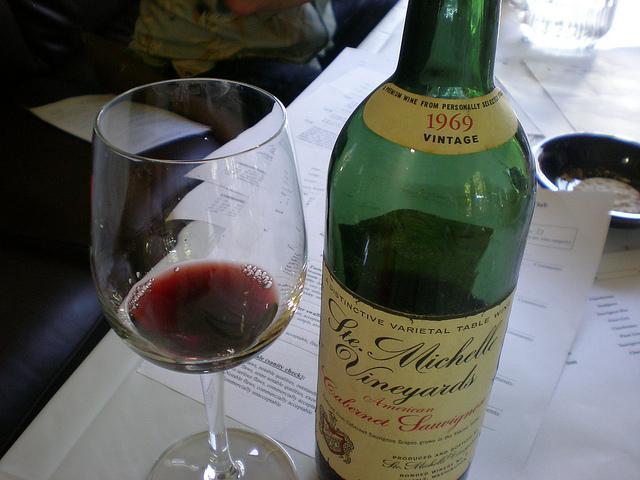How many glasses can be seen?
Give a very brief answer. 1. How many wine glasses?
Give a very brief answer. 1. How many bottles are there?
Give a very brief answer. 1. How many glasses are on the table?
Give a very brief answer. 2. How many wine glasses are there?
Give a very brief answer. 1. How many people are there?
Give a very brief answer. 1. 